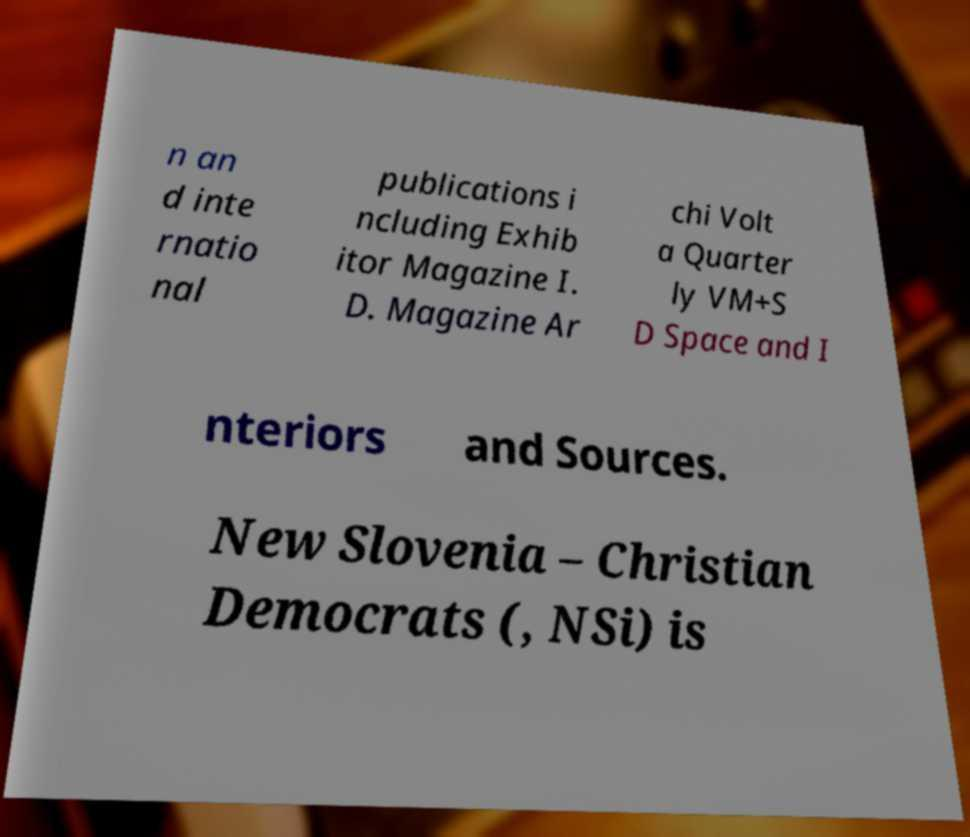Can you read and provide the text displayed in the image?This photo seems to have some interesting text. Can you extract and type it out for me? n an d inte rnatio nal publications i ncluding Exhib itor Magazine I. D. Magazine Ar chi Volt a Quarter ly VM+S D Space and I nteriors and Sources. New Slovenia – Christian Democrats (, NSi) is 